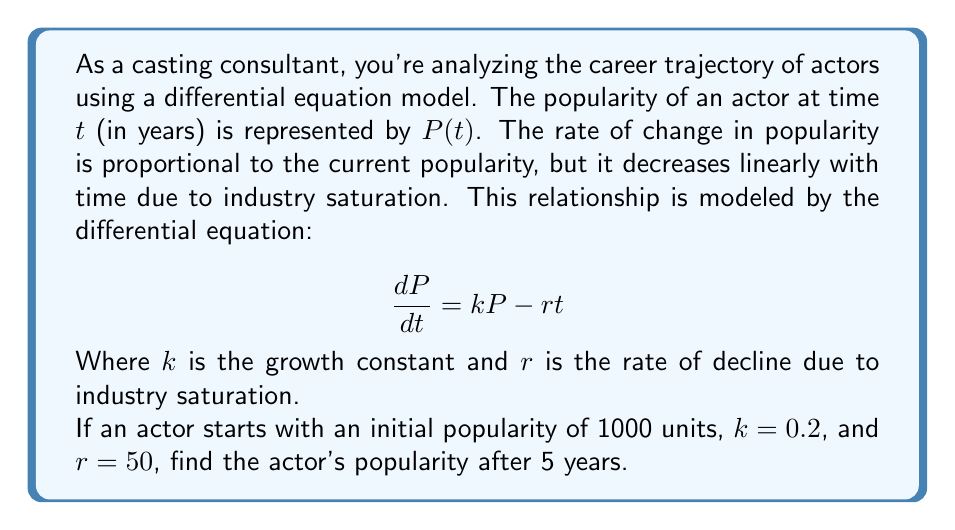Solve this math problem. To solve this problem, we need to follow these steps:

1) First, we need to solve the given differential equation:
   $$\frac{dP}{dt} = kP - rt$$

2) This is a linear first-order differential equation. We can solve it using the integrating factor method.

3) The integrating factor is $e^{-kt}$. Multiplying both sides by this:
   $$e^{-kt}\frac{dP}{dt} - kPe^{-kt} = -rte^{-kt}$$

4) The left side is now the derivative of $Pe^{-kt}$:
   $$\frac{d}{dt}(Pe^{-kt}) = -rte^{-kt}$$

5) Integrating both sides:
   $$Pe^{-kt} = r\frac{t}{k}e^{-kt} - r\frac{1}{k^2}e^{-kt} + C$$

6) Solving for P:
   $$P = r\frac{t}{k} - r\frac{1}{k^2} + Ce^{kt}$$

7) Using the initial condition P(0) = 1000:
   $$1000 = -r\frac{1}{k^2} + C$$
   $$C = 1000 + r\frac{1}{k^2}$$

8) Substituting back:
   $$P(t) = r\frac{t}{k} - r\frac{1}{k^2} + (1000 + r\frac{1}{k^2})e^{kt}$$

9) Now we can substitute the given values: k = 0.2, r = 50, t = 5:
   $$P(5) = 50\frac{5}{0.2} - 50\frac{1}{0.2^2} + (1000 + 50\frac{1}{0.2^2})e^{0.2*5}$$

10) Simplifying:
    $$P(5) = 1250 - 1250 + (1000 + 1250)e^{1}$$
    $$P(5) = 2250e^{1} \approx 6116.98$$

Therefore, the actor's popularity after 5 years will be approximately 6117 units.
Answer: 6117 units 